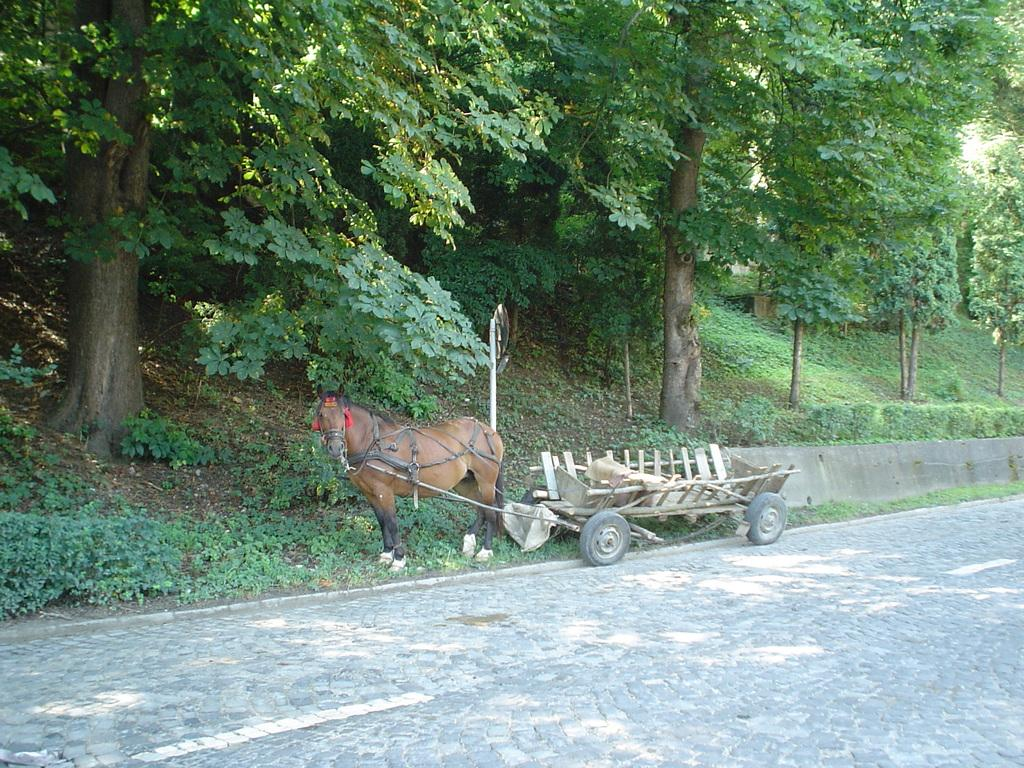Where was the image taken? The image was taken beside a road. What animal is present in the image? There is a horse in the image. How is the horse connected to the cart? The horse is tied with a rope to a cart. What type of vegetation can be seen in the image? Trees and plants are visible at the top of the image. How many zebras are present in the image? There are no zebras present in the image; it features a horse. What type of eggs can be seen in the image? There are no eggs present in the image. 